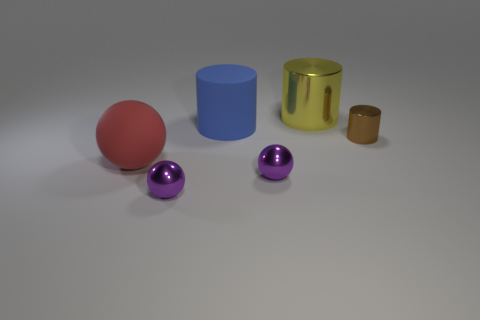There is a cylinder that is in front of the yellow shiny object and right of the large blue rubber object; what is its color?
Make the answer very short. Brown. Are there fewer small spheres right of the small brown thing than blue matte things behind the red ball?
Offer a very short reply. Yes. Are there any other things that have the same color as the big rubber ball?
Offer a terse response. No. The tiny brown object has what shape?
Ensure brevity in your answer.  Cylinder. What is the color of the other thing that is made of the same material as the big red object?
Your response must be concise. Blue. Is the number of small brown things greater than the number of tiny green rubber cylinders?
Give a very brief answer. Yes. Is there a big green rubber ball?
Your response must be concise. No. The large thing to the left of the rubber thing behind the red object is what shape?
Offer a very short reply. Sphere. How many things are blue rubber things or metal objects behind the big red matte thing?
Offer a terse response. 3. There is a tiny metal ball on the right side of the small purple metal object that is on the left side of the big matte cylinder that is behind the small metallic cylinder; what is its color?
Your answer should be compact. Purple. 